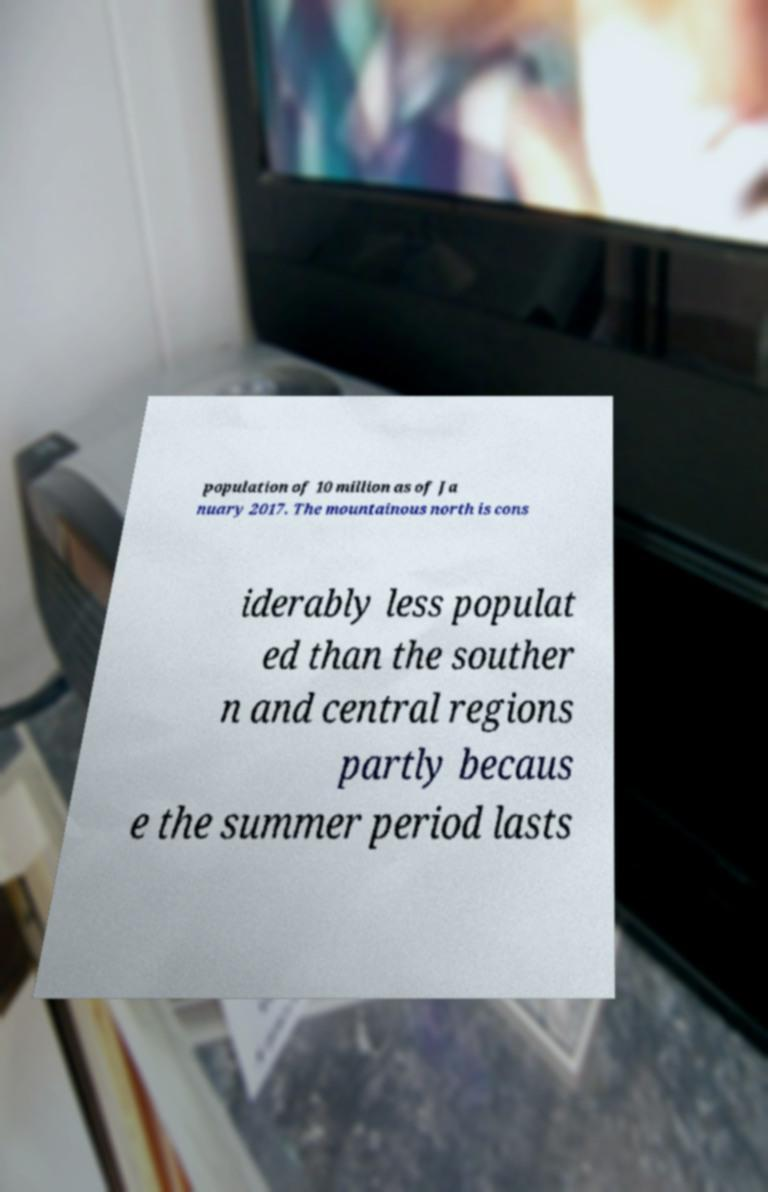Please read and relay the text visible in this image. What does it say? population of 10 million as of Ja nuary 2017. The mountainous north is cons iderably less populat ed than the souther n and central regions partly becaus e the summer period lasts 